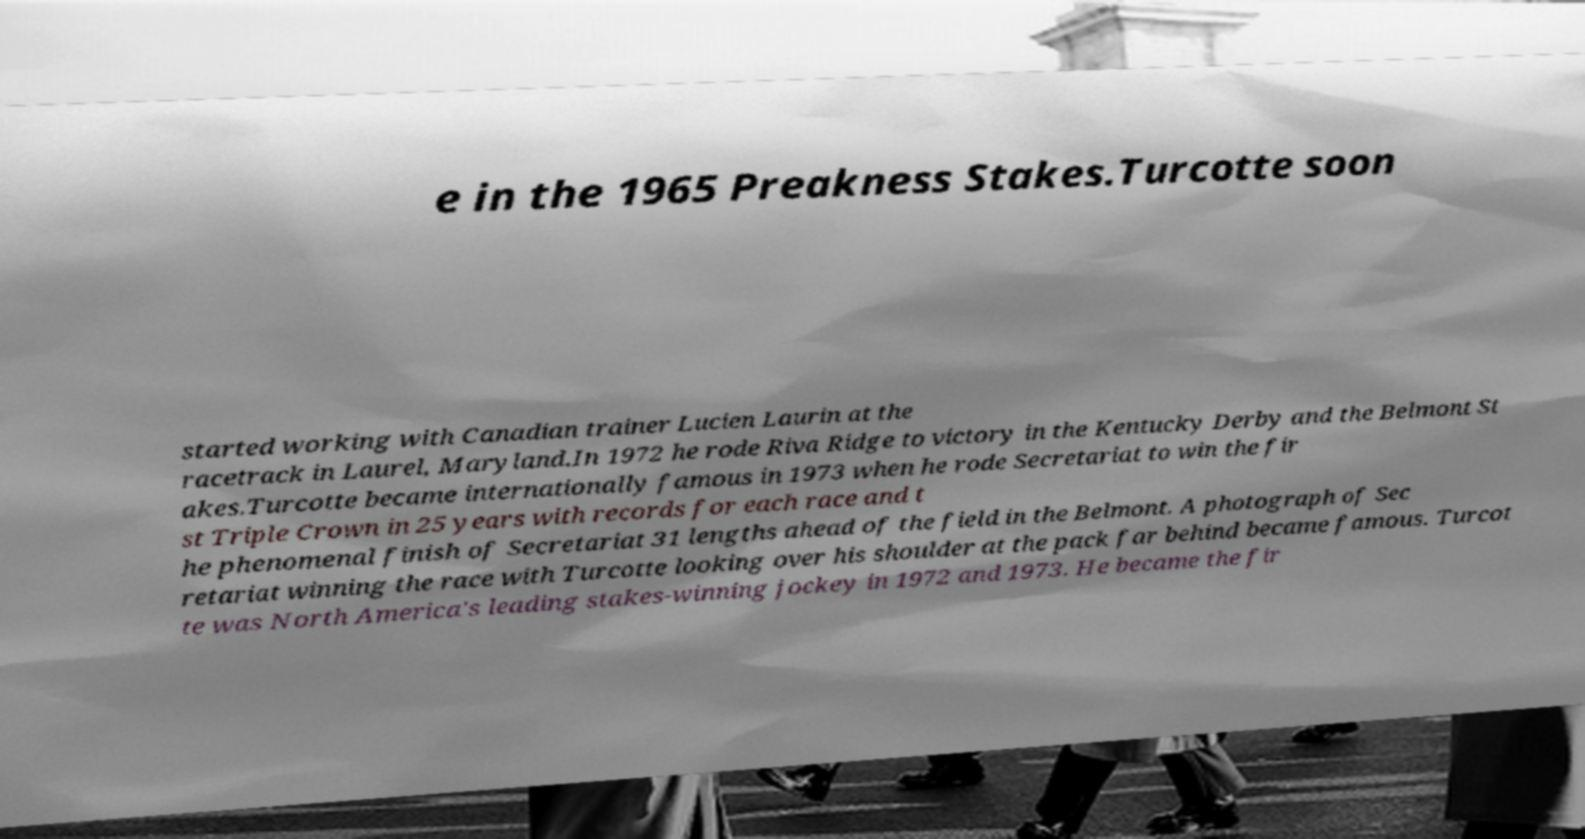Could you assist in decoding the text presented in this image and type it out clearly? e in the 1965 Preakness Stakes.Turcotte soon started working with Canadian trainer Lucien Laurin at the racetrack in Laurel, Maryland.In 1972 he rode Riva Ridge to victory in the Kentucky Derby and the Belmont St akes.Turcotte became internationally famous in 1973 when he rode Secretariat to win the fir st Triple Crown in 25 years with records for each race and t he phenomenal finish of Secretariat 31 lengths ahead of the field in the Belmont. A photograph of Sec retariat winning the race with Turcotte looking over his shoulder at the pack far behind became famous. Turcot te was North America's leading stakes-winning jockey in 1972 and 1973. He became the fir 